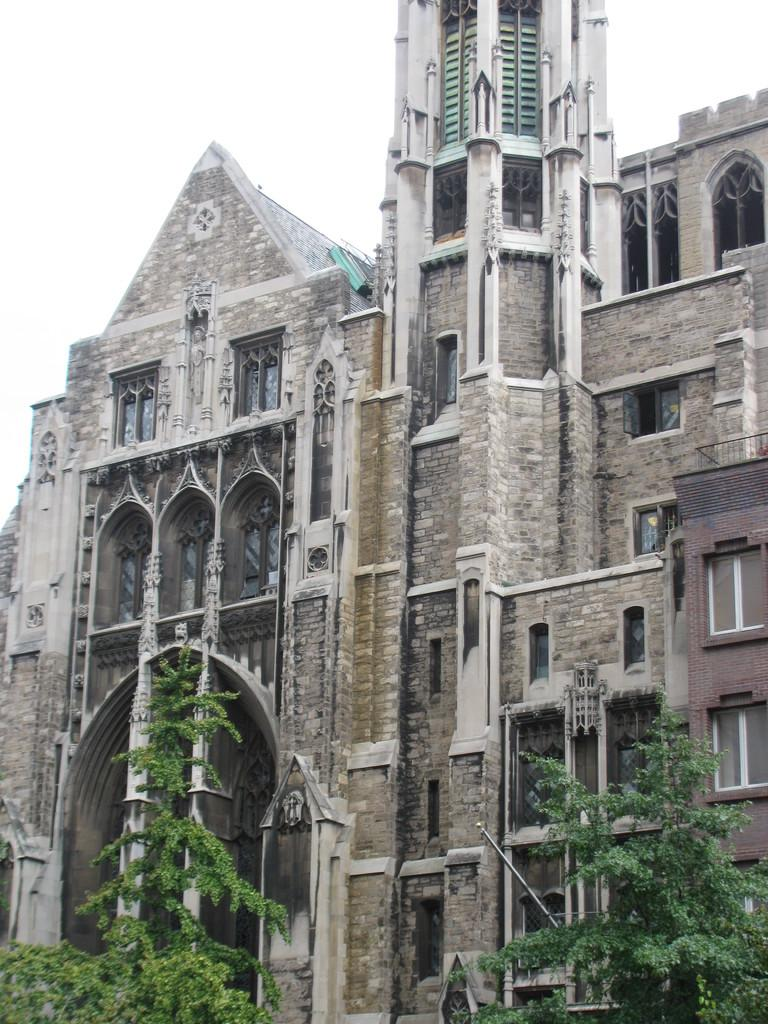What is the main structure in the image? There is a building in the image. What feature can be seen on the building? The building has a group of windows. What type of vegetation is present in the foreground of the image? There is a group of trees in the foreground of the image. What can be seen in the background of the image? The sky is visible in the background of the image. What type of liquid can be seen flowing from the windows of the building in the image? There is no liquid flowing from the windows of the building in the image. 